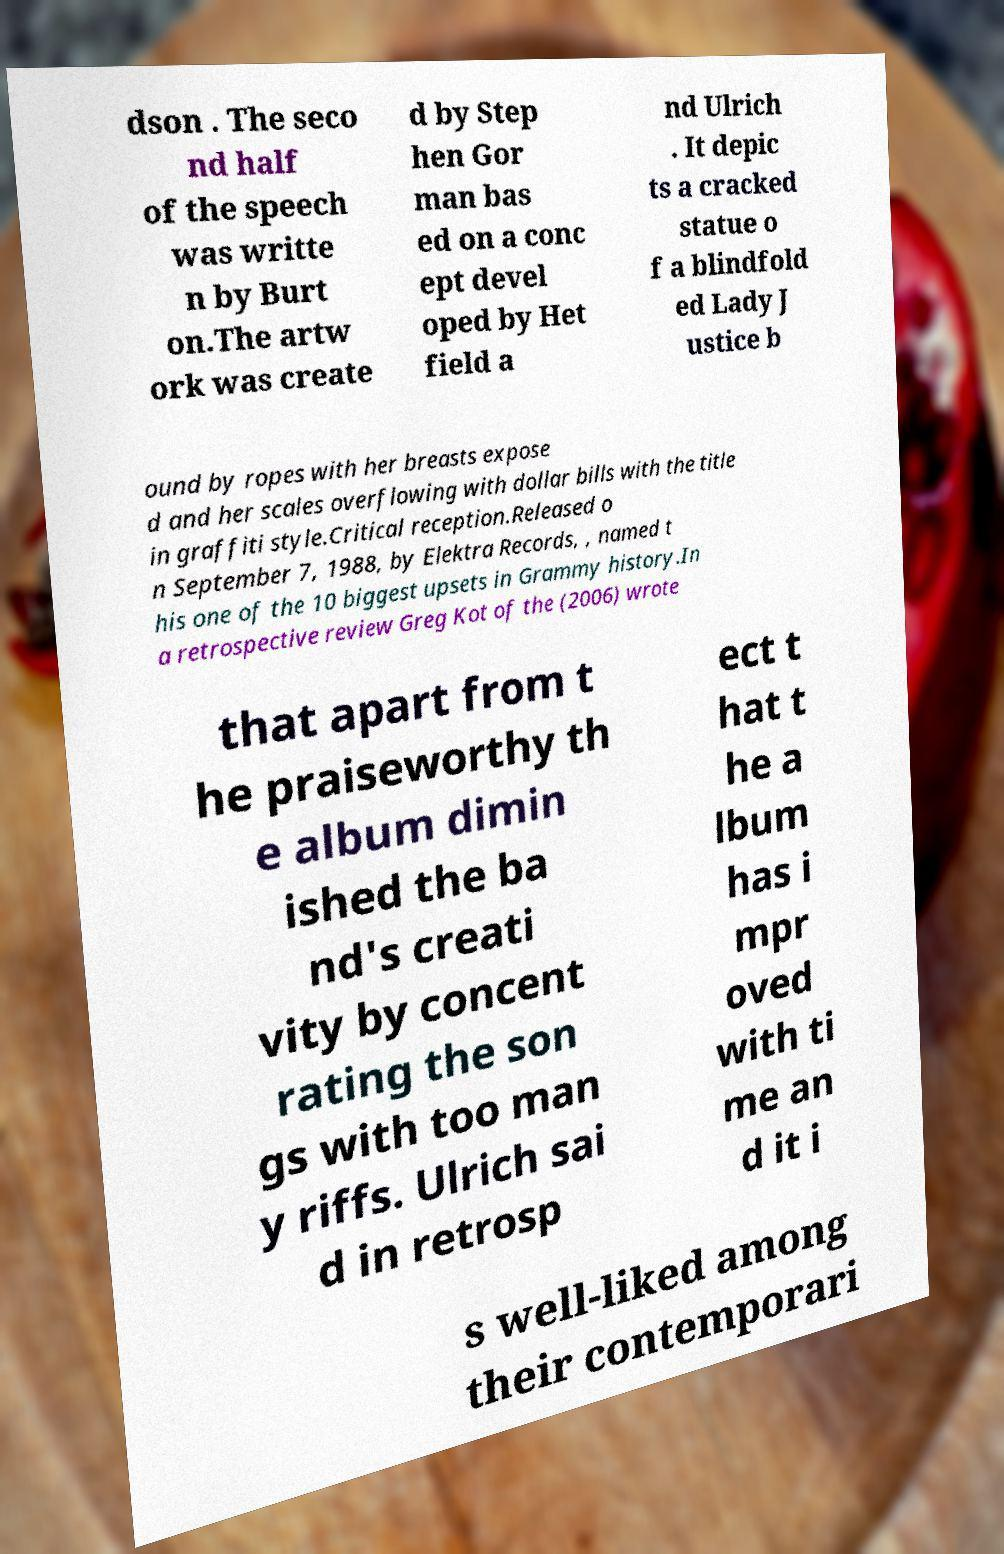Can you accurately transcribe the text from the provided image for me? dson . The seco nd half of the speech was writte n by Burt on.The artw ork was create d by Step hen Gor man bas ed on a conc ept devel oped by Het field a nd Ulrich . It depic ts a cracked statue o f a blindfold ed Lady J ustice b ound by ropes with her breasts expose d and her scales overflowing with dollar bills with the title in graffiti style.Critical reception.Released o n September 7, 1988, by Elektra Records, , named t his one of the 10 biggest upsets in Grammy history.In a retrospective review Greg Kot of the (2006) wrote that apart from t he praiseworthy th e album dimin ished the ba nd's creati vity by concent rating the son gs with too man y riffs. Ulrich sai d in retrosp ect t hat t he a lbum has i mpr oved with ti me an d it i s well-liked among their contemporari 